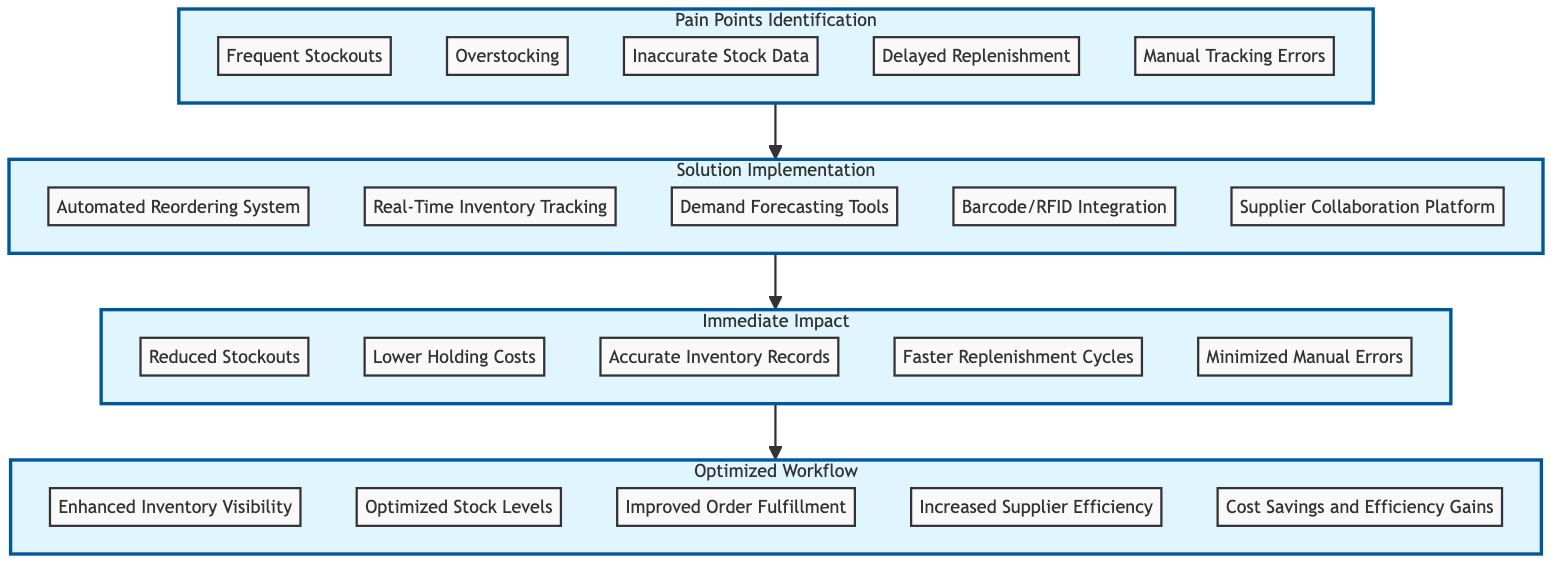What are the pain points identified in the current inventory process? According to the diagram, the elements listed under the "Pain Points Identification" level include frequent stockouts, overstocking, inaccurate stock data, delayed replenishment, and manual tracking errors.
Answer: Frequent Stockouts, Overstocking, Inaccurate Stock Data, Delayed Replenishment, Manual Tracking Errors How many solutions are implemented to address the pain points? The "Solution Implementation" level contains five elements. Therefore, the number of solutions implemented to address the pain points is five.
Answer: 5 What is the immediate impact of implementing the solutions? The immediate impacts outlined in the diagram include reduced stockouts, lower holding costs, accurate inventory records, faster replenishment cycles, and minimized manual errors.
Answer: Reduced Stockouts, Lower Holding Costs, Accurate Inventory Records, Faster Replenishment Cycles, Minimized Manual Errors Which solution leads to reduced stockouts? The direct connection from the "Solution Implementation" level to the "Immediate Impact" level indicates that solutions such as an automated reordering system and real-time inventory tracking are designed to reduce stockouts.
Answer: Automated Reordering System, Real-Time Inventory Tracking What is the final outcome of the optimized workflow? Looking at the "Optimized Workflow" level, the final outcomes include enhanced inventory visibility, optimized stock levels, improved order fulfillment, increased supplier efficiency, and cost savings and efficiency gains.
Answer: Enhanced Inventory Visibility, Optimized Stock Levels, Improved Order Fulfillment, Increased Supplier Efficiency, Cost Savings and Efficiency Gains What is the relationship between pain points and optimized workflow? The diagram shows a bottom-to-top flow where each level builds upon the previous one, indicating that addressing pain points leads to implementing solutions which then result in immediate impacts, ultimately leading to an optimized workflow.
Answer: Causal Relationship How many immediate impacts are listed in the diagram? There are five elements listed under the "Immediate Impact" level in the flowchart. Therefore, the number of immediate impacts is five.
Answer: 5 Which identified pain point is directly related to manual tracking? The specific pain point related to manual tracking is the "Manual Tracking Errors," which emphasizes inaccuracies resulting from a failure to utilize automated systems.
Answer: Manual Tracking Errors Which element enhances supplier efficiency? Within the "Optimized Workflow" level, the element that enhances supplier efficiency is labeled "Increased Supplier Efficiency."
Answer: Increased Supplier Efficiency 